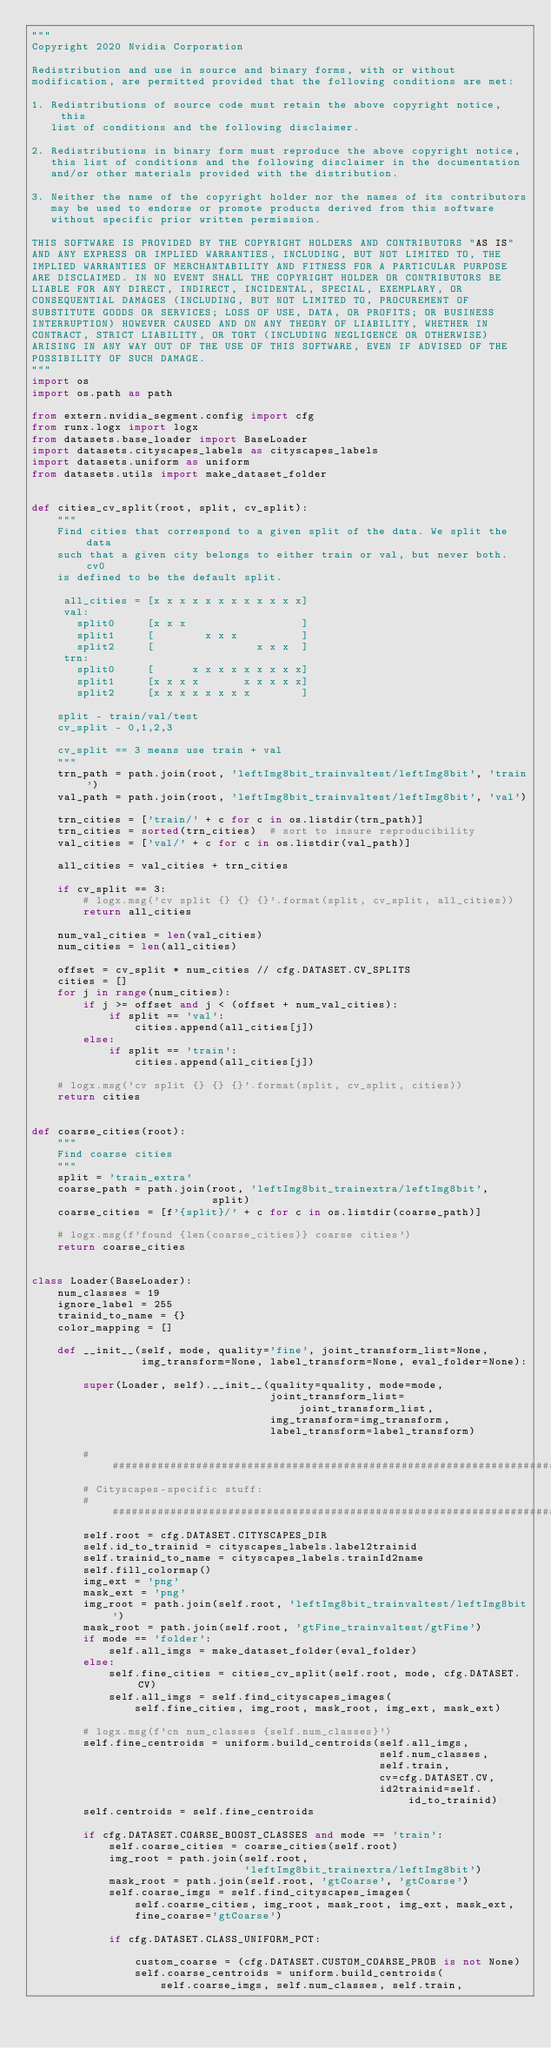Convert code to text. <code><loc_0><loc_0><loc_500><loc_500><_Python_>"""
Copyright 2020 Nvidia Corporation

Redistribution and use in source and binary forms, with or without
modification, are permitted provided that the following conditions are met:

1. Redistributions of source code must retain the above copyright notice, this
   list of conditions and the following disclaimer.

2. Redistributions in binary form must reproduce the above copyright notice,
   this list of conditions and the following disclaimer in the documentation
   and/or other materials provided with the distribution.

3. Neither the name of the copyright holder nor the names of its contributors
   may be used to endorse or promote products derived from this software
   without specific prior written permission.

THIS SOFTWARE IS PROVIDED BY THE COPYRIGHT HOLDERS AND CONTRIBUTORS "AS IS"
AND ANY EXPRESS OR IMPLIED WARRANTIES, INCLUDING, BUT NOT LIMITED TO, THE
IMPLIED WARRANTIES OF MERCHANTABILITY AND FITNESS FOR A PARTICULAR PURPOSE
ARE DISCLAIMED. IN NO EVENT SHALL THE COPYRIGHT HOLDER OR CONTRIBUTORS BE
LIABLE FOR ANY DIRECT, INDIRECT, INCIDENTAL, SPECIAL, EXEMPLARY, OR
CONSEQUENTIAL DAMAGES (INCLUDING, BUT NOT LIMITED TO, PROCUREMENT OF
SUBSTITUTE GOODS OR SERVICES; LOSS OF USE, DATA, OR PROFITS; OR BUSINESS
INTERRUPTION) HOWEVER CAUSED AND ON ANY THEORY OF LIABILITY, WHETHER IN
CONTRACT, STRICT LIABILITY, OR TORT (INCLUDING NEGLIGENCE OR OTHERWISE)
ARISING IN ANY WAY OUT OF THE USE OF THIS SOFTWARE, EVEN IF ADVISED OF THE
POSSIBILITY OF SUCH DAMAGE.
"""
import os
import os.path as path

from extern.nvidia_segment.config import cfg
from runx.logx import logx
from datasets.base_loader import BaseLoader
import datasets.cityscapes_labels as cityscapes_labels
import datasets.uniform as uniform
from datasets.utils import make_dataset_folder


def cities_cv_split(root, split, cv_split):
    """
    Find cities that correspond to a given split of the data. We split the data
    such that a given city belongs to either train or val, but never both. cv0
    is defined to be the default split.

     all_cities = [x x x x x x x x x x x x]
     val:
       split0     [x x x                  ]
       split1     [        x x x          ]
       split2     [                x x x  ]
     trn:
       split0     [      x x x x x x x x x]
       split1     [x x x x       x x x x x]
       split2     [x x x x x x x x        ]

    split - train/val/test
    cv_split - 0,1,2,3

    cv_split == 3 means use train + val
    """
    trn_path = path.join(root, 'leftImg8bit_trainvaltest/leftImg8bit', 'train')
    val_path = path.join(root, 'leftImg8bit_trainvaltest/leftImg8bit', 'val')

    trn_cities = ['train/' + c for c in os.listdir(trn_path)]
    trn_cities = sorted(trn_cities)  # sort to insure reproducibility
    val_cities = ['val/' + c for c in os.listdir(val_path)]

    all_cities = val_cities + trn_cities

    if cv_split == 3:
        # logx.msg('cv split {} {} {}'.format(split, cv_split, all_cities))
        return all_cities

    num_val_cities = len(val_cities)
    num_cities = len(all_cities)

    offset = cv_split * num_cities // cfg.DATASET.CV_SPLITS
    cities = []
    for j in range(num_cities):
        if j >= offset and j < (offset + num_val_cities):
            if split == 'val':
                cities.append(all_cities[j])
        else:
            if split == 'train':
                cities.append(all_cities[j])

    # logx.msg('cv split {} {} {}'.format(split, cv_split, cities))
    return cities


def coarse_cities(root):
    """
    Find coarse cities
    """
    split = 'train_extra'
    coarse_path = path.join(root, 'leftImg8bit_trainextra/leftImg8bit',
                            split)
    coarse_cities = [f'{split}/' + c for c in os.listdir(coarse_path)]

    # logx.msg(f'found {len(coarse_cities)} coarse cities')
    return coarse_cities


class Loader(BaseLoader):
    num_classes = 19
    ignore_label = 255
    trainid_to_name = {}
    color_mapping = []

    def __init__(self, mode, quality='fine', joint_transform_list=None,
                 img_transform=None, label_transform=None, eval_folder=None):

        super(Loader, self).__init__(quality=quality, mode=mode,
                                     joint_transform_list=joint_transform_list,
                                     img_transform=img_transform,
                                     label_transform=label_transform)

        ######################################################################
        # Cityscapes-specific stuff:
        ######################################################################
        self.root = cfg.DATASET.CITYSCAPES_DIR
        self.id_to_trainid = cityscapes_labels.label2trainid
        self.trainid_to_name = cityscapes_labels.trainId2name
        self.fill_colormap()
        img_ext = 'png'
        mask_ext = 'png'
        img_root = path.join(self.root, 'leftImg8bit_trainvaltest/leftImg8bit')
        mask_root = path.join(self.root, 'gtFine_trainvaltest/gtFine')
        if mode == 'folder':
            self.all_imgs = make_dataset_folder(eval_folder)
        else:
            self.fine_cities = cities_cv_split(self.root, mode, cfg.DATASET.CV)
            self.all_imgs = self.find_cityscapes_images(
                self.fine_cities, img_root, mask_root, img_ext, mask_ext)

        # logx.msg(f'cn num_classes {self.num_classes}')
        self.fine_centroids = uniform.build_centroids(self.all_imgs,
                                                      self.num_classes,
                                                      self.train,
                                                      cv=cfg.DATASET.CV,
                                                      id2trainid=self.id_to_trainid)
        self.centroids = self.fine_centroids

        if cfg.DATASET.COARSE_BOOST_CLASSES and mode == 'train':
            self.coarse_cities = coarse_cities(self.root)
            img_root = path.join(self.root,
                                 'leftImg8bit_trainextra/leftImg8bit')
            mask_root = path.join(self.root, 'gtCoarse', 'gtCoarse')
            self.coarse_imgs = self.find_cityscapes_images(
                self.coarse_cities, img_root, mask_root, img_ext, mask_ext,
                fine_coarse='gtCoarse')

            if cfg.DATASET.CLASS_UNIFORM_PCT:   
                
                custom_coarse = (cfg.DATASET.CUSTOM_COARSE_PROB is not None)
                self.coarse_centroids = uniform.build_centroids(
                    self.coarse_imgs, self.num_classes, self.train,</code> 